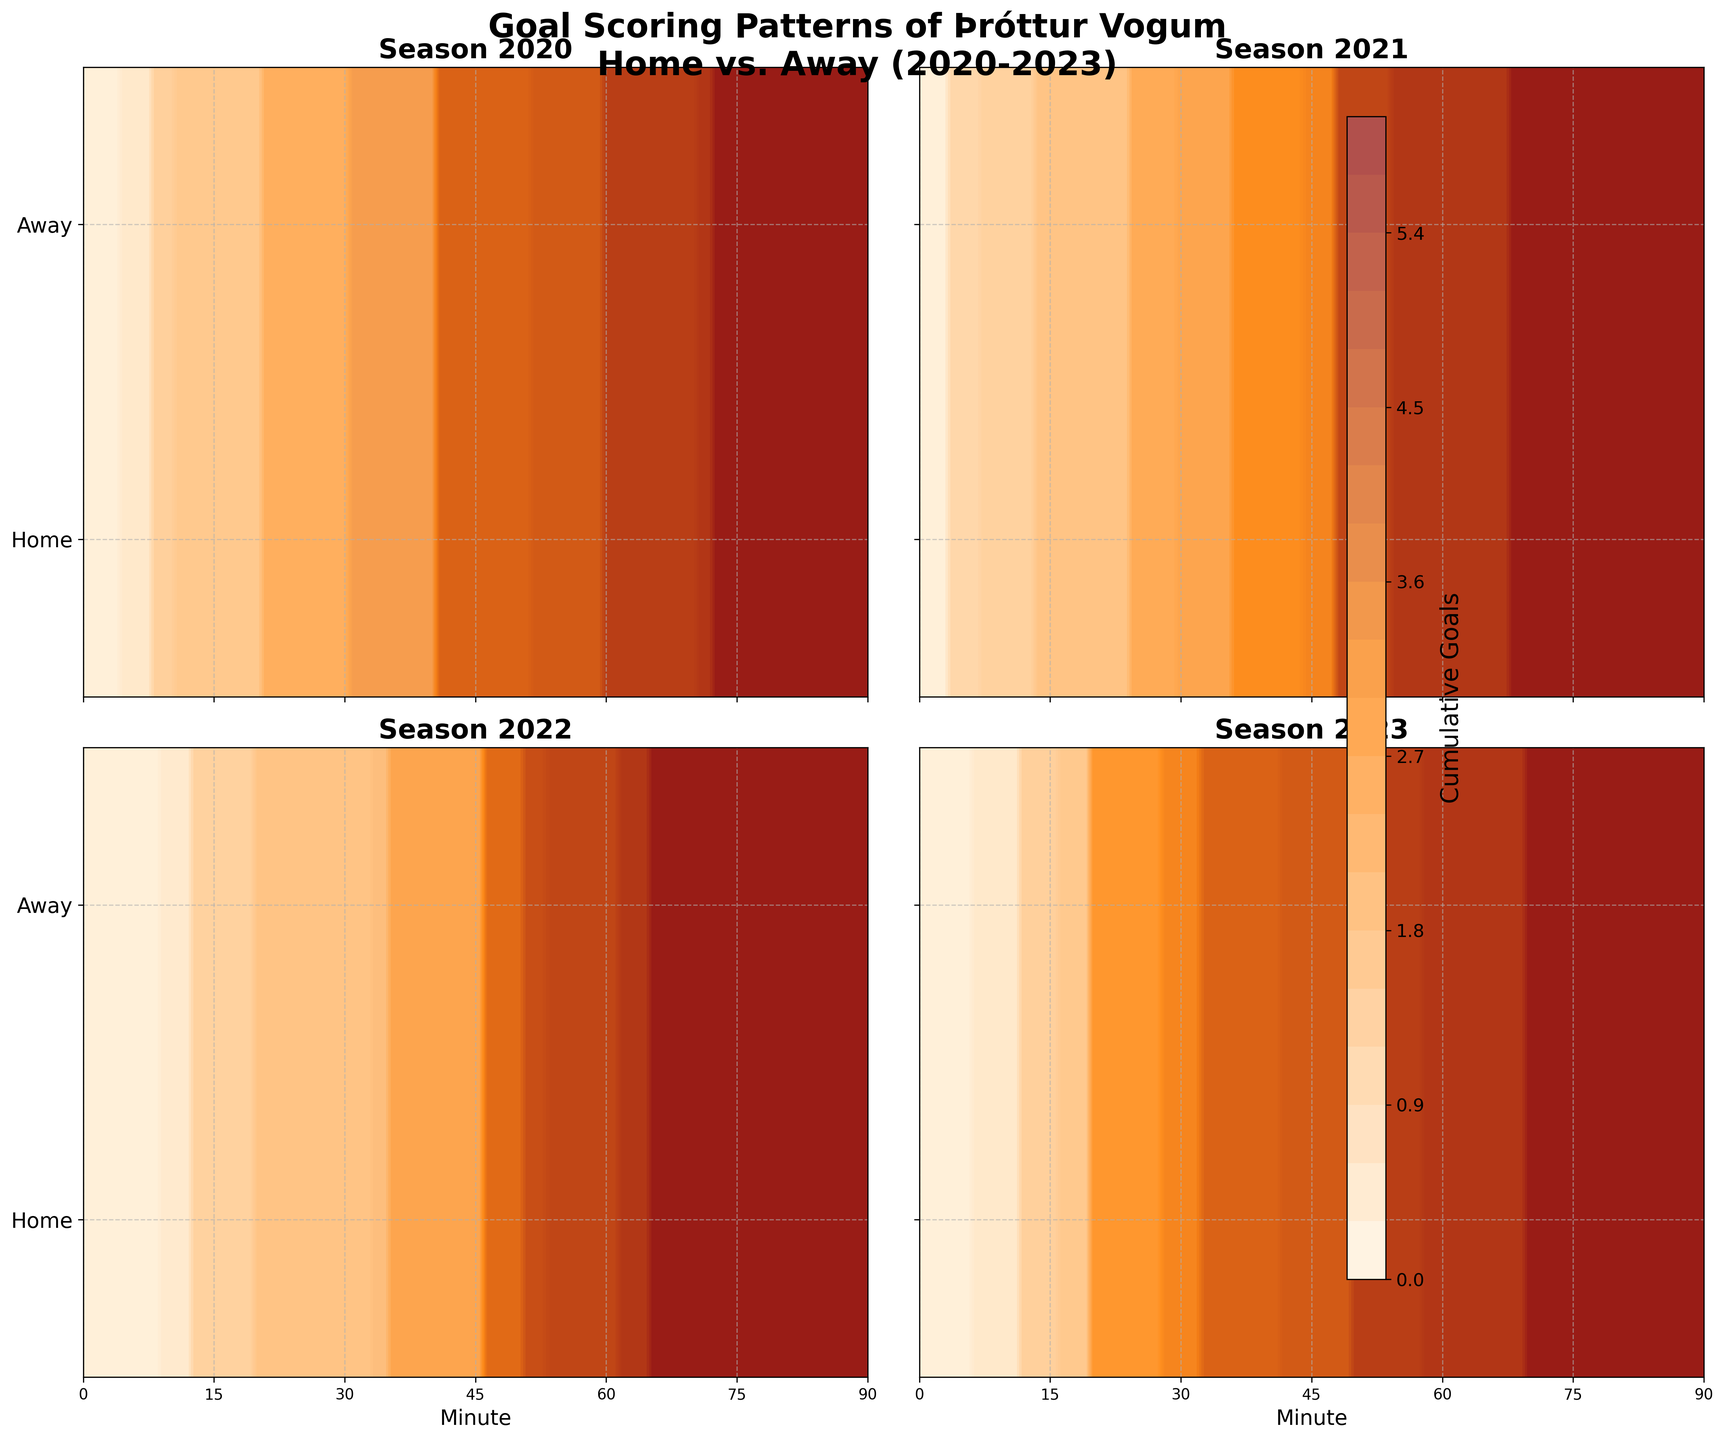What's the title of the figure? The title is typically placed at the top and describes the overall content of the figure. The figure's title is "Goal Scoring Patterns of Þróttur Vogum Home vs. Away (2020-2023)."
Answer: Goal Scoring Patterns of Þróttur Vogum Home vs. Away (2020-2023) How are the subplots organized? The subplots are usually organized in a grid format, and in this figure, they are arranged in a 2x2 grid.
Answer: 2x2 grid What does the y-axis represent? By examining the y-axis labels, it can be seen that it differentiates between 'Home' and 'Away' scoring patterns. It uses a categorical representation set at 0.25 for Home and 0.75 for Away.
Answer: Home and Away locations During which season did Þróttur Vogum score the most goals at home in the initial 15 minutes? We need to check the goal contour plot in each season's subplot for the home team (value around 0 on the y-axis) within the initial 15-minute window on the x-axis to see which has the highest cumulative goals. The season with the thickest cumulative contour closest to the leftmost side represents the most goals.
Answer: 2021 Which season had the most balanced goal-scoring pattern between home and away games? Balance can be determined by comparing the cumulative goal contours for home and away games across different seasons. The season where there isn't a stark difference between home and away contours likely shows a balanced scoring pattern.
Answer: 2023 What can you infer from the color gradients used in the plots? The color gradients indicate the intensity of cumulative goals scored, with different shades representing varying levels of cumulative goals, from lowest (closer to white) to highest (darker shades).
Answer: Intensity of cumulative goals How many seasons are represented in the figure? Each subplot represents a season, so counting the number of subplots gives the total number of seasons represented in the figure. There are four subplots in total.
Answer: Four seasons Is Þróttur Vogum more consistent in scoring at home or away? Consistency can be inferred from the contour density and spread. A narrower spread and higher density in the contour plots indicate more consistent scoring. Comparing the home (y=0) and away (y=1) contours, we need to see which has a more consistent and intensified goal contour.
Answer: Home In which seasons did Þróttur Vogum have similar scoring times both at home and away? We need to examine the contour plots for both locations within each season's subplot, looking for overlap or similar shapes and positions in the subplots of home (y=0) and away (y=1) games. The most overlapping contours indicate similar scoring times.
Answer: 2022 and 2023 What can be said about the goal-scoring trend in away games during the 2020 season? By referring to the subplot for the 2020 season and focusing on the away games (y=1), we observe the distribution and gradient of contours over the match minutes to understand the trend. In the 2020 subplot, goal contours are relatively consistent across the match.
Answer: Consistent scoring across minutes 